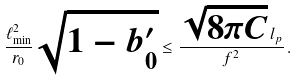<formula> <loc_0><loc_0><loc_500><loc_500>\frac { \ell ^ { 2 } _ { \min } } { r _ { 0 } } \sqrt { 1 - b ^ { \prime } _ { 0 } } \leq \frac { \sqrt { 8 \pi C } \, l _ { p } } { f ^ { 2 } } \, .</formula> 